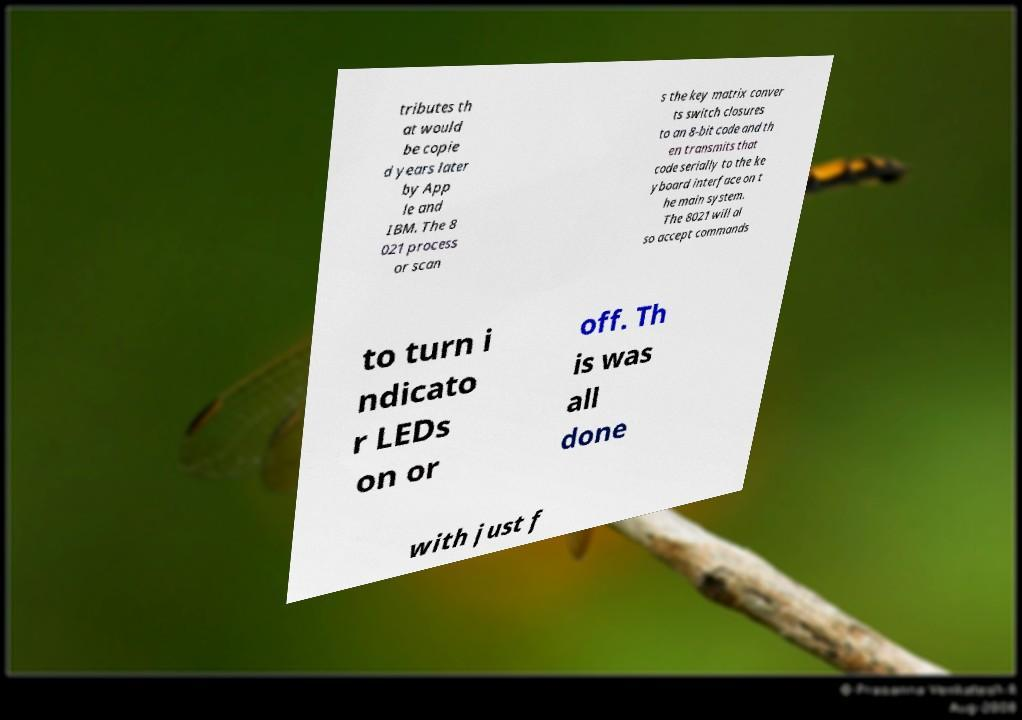For documentation purposes, I need the text within this image transcribed. Could you provide that? tributes th at would be copie d years later by App le and IBM. The 8 021 process or scan s the key matrix conver ts switch closures to an 8-bit code and th en transmits that code serially to the ke yboard interface on t he main system. The 8021 will al so accept commands to turn i ndicato r LEDs on or off. Th is was all done with just f 